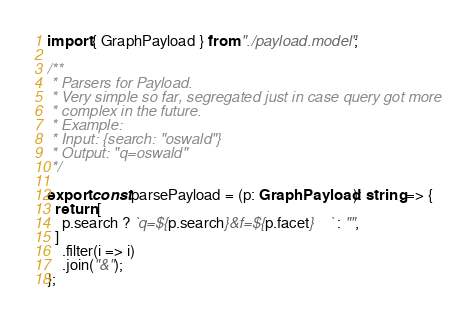<code> <loc_0><loc_0><loc_500><loc_500><_TypeScript_>import { GraphPayload } from "./payload.model";

/**
 * Parsers for Payload.
 * Very simple so far, segregated just in case query got more
 * complex in the future.
 * Example:
 * Input: {search: "oswald"}
 * Output: "q=oswald"
 */

export const parsePayload = (p: GraphPayload): string => {
  return [
    p.search ? `q=${p.search}&f=${p.facet}    ` : "",
  ]
    .filter(i => i)
    .join("&");
};
</code> 